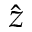Convert formula to latex. <formula><loc_0><loc_0><loc_500><loc_500>\hat { z }</formula> 